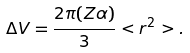<formula> <loc_0><loc_0><loc_500><loc_500>\Delta V = \frac { 2 \pi ( Z \alpha ) } { 3 } < r ^ { 2 } > .</formula> 